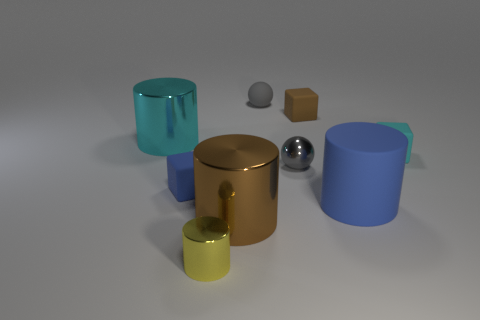Subtract all matte cylinders. How many cylinders are left? 3 Subtract all cyan blocks. How many blocks are left? 2 Subtract 1 gray spheres. How many objects are left? 8 Subtract all blocks. How many objects are left? 6 Subtract 3 blocks. How many blocks are left? 0 Subtract all yellow cubes. Subtract all yellow balls. How many cubes are left? 3 Subtract all gray blocks. How many blue cylinders are left? 1 Subtract all big green rubber blocks. Subtract all brown things. How many objects are left? 7 Add 2 small metal things. How many small metal things are left? 4 Add 3 cyan things. How many cyan things exist? 5 